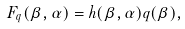<formula> <loc_0><loc_0><loc_500><loc_500>F _ { q } ( \beta , \alpha ) = h ( \beta , \alpha ) q ( \beta ) ,</formula> 